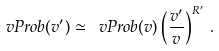Convert formula to latex. <formula><loc_0><loc_0><loc_500><loc_500>\ v P r o b ( v ^ { \prime } ) \simeq \ v P r o b ( v ) \left ( \frac { v ^ { \prime } } { v } \right ) ^ { R ^ { \prime } } \, .</formula> 